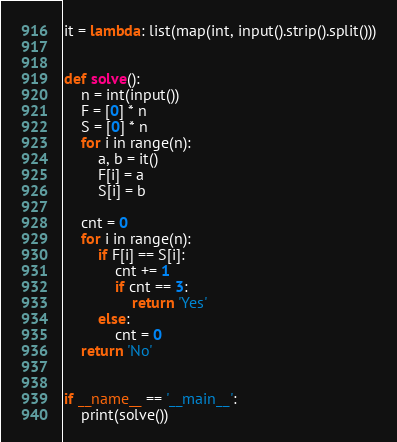<code> <loc_0><loc_0><loc_500><loc_500><_Python_>it = lambda: list(map(int, input().strip().split()))


def solve():
    n = int(input())
    F = [0] * n
    S = [0] * n
    for i in range(n):
        a, b = it()
        F[i] = a
        S[i] = b
    
    cnt = 0
    for i in range(n):
        if F[i] == S[i]:
            cnt += 1
            if cnt == 3:
                return 'Yes'
        else:
            cnt = 0
    return 'No'


if __name__ == '__main__':
    print(solve())</code> 